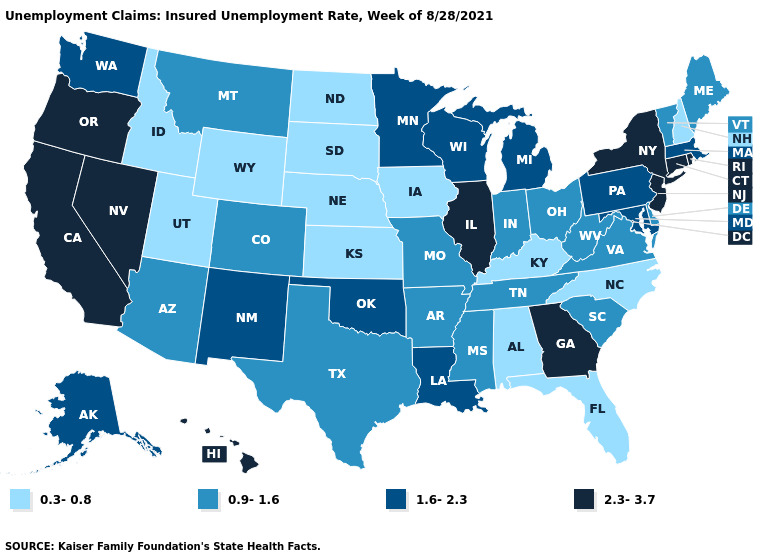What is the value of Nevada?
Keep it brief. 2.3-3.7. Name the states that have a value in the range 2.3-3.7?
Keep it brief. California, Connecticut, Georgia, Hawaii, Illinois, Nevada, New Jersey, New York, Oregon, Rhode Island. Which states hav the highest value in the West?
Give a very brief answer. California, Hawaii, Nevada, Oregon. What is the lowest value in the USA?
Answer briefly. 0.3-0.8. Name the states that have a value in the range 1.6-2.3?
Quick response, please. Alaska, Louisiana, Maryland, Massachusetts, Michigan, Minnesota, New Mexico, Oklahoma, Pennsylvania, Washington, Wisconsin. What is the lowest value in states that border Vermont?
Keep it brief. 0.3-0.8. What is the value of Nebraska?
Keep it brief. 0.3-0.8. Name the states that have a value in the range 0.3-0.8?
Be succinct. Alabama, Florida, Idaho, Iowa, Kansas, Kentucky, Nebraska, New Hampshire, North Carolina, North Dakota, South Dakota, Utah, Wyoming. Name the states that have a value in the range 0.9-1.6?
Be succinct. Arizona, Arkansas, Colorado, Delaware, Indiana, Maine, Mississippi, Missouri, Montana, Ohio, South Carolina, Tennessee, Texas, Vermont, Virginia, West Virginia. What is the value of Idaho?
Be succinct. 0.3-0.8. What is the lowest value in the Northeast?
Quick response, please. 0.3-0.8. Among the states that border Colorado , which have the lowest value?
Be succinct. Kansas, Nebraska, Utah, Wyoming. Which states hav the highest value in the West?
Answer briefly. California, Hawaii, Nevada, Oregon. Name the states that have a value in the range 0.9-1.6?
Answer briefly. Arizona, Arkansas, Colorado, Delaware, Indiana, Maine, Mississippi, Missouri, Montana, Ohio, South Carolina, Tennessee, Texas, Vermont, Virginia, West Virginia. Among the states that border Virginia , does Kentucky have the highest value?
Quick response, please. No. 